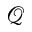<formula> <loc_0><loc_0><loc_500><loc_500>\mathcal { Q }</formula> 